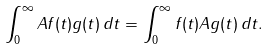<formula> <loc_0><loc_0><loc_500><loc_500>\int _ { 0 } ^ { \infty } A f ( t ) g ( t ) \, d t = \int _ { 0 } ^ { \infty } f ( t ) A g ( t ) \, d t .</formula> 